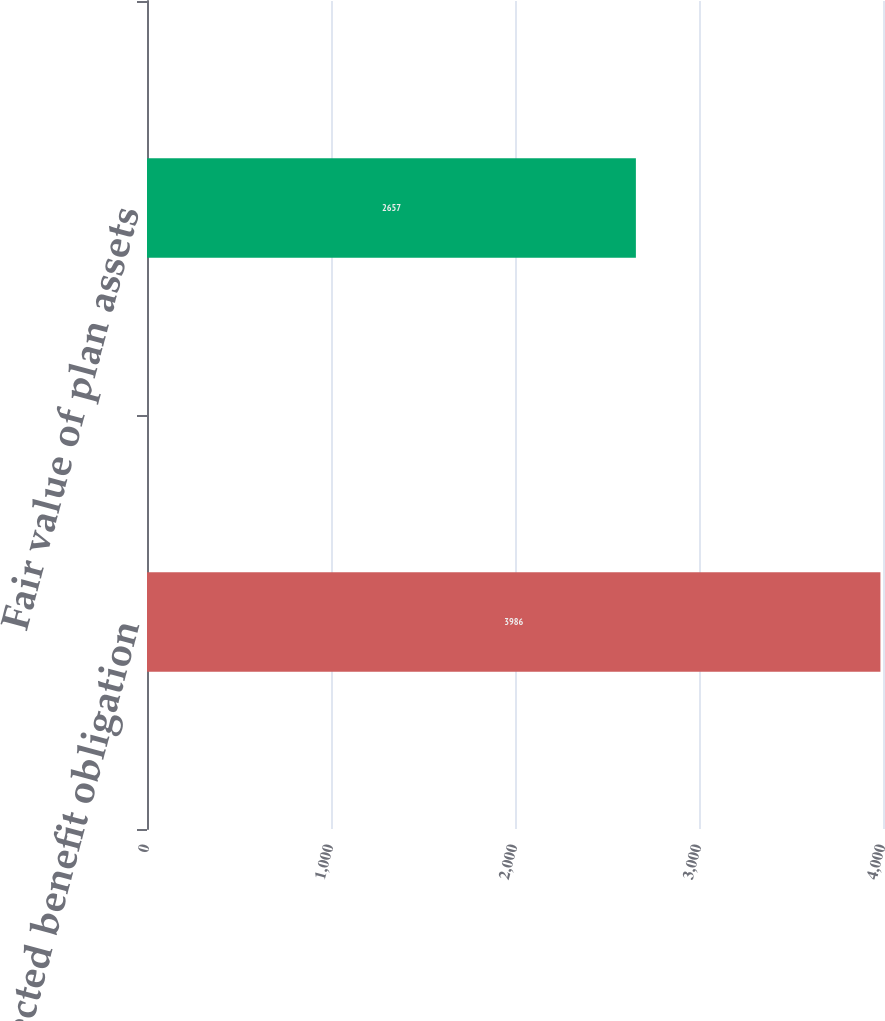Convert chart. <chart><loc_0><loc_0><loc_500><loc_500><bar_chart><fcel>Projected benefit obligation<fcel>Fair value of plan assets<nl><fcel>3986<fcel>2657<nl></chart> 